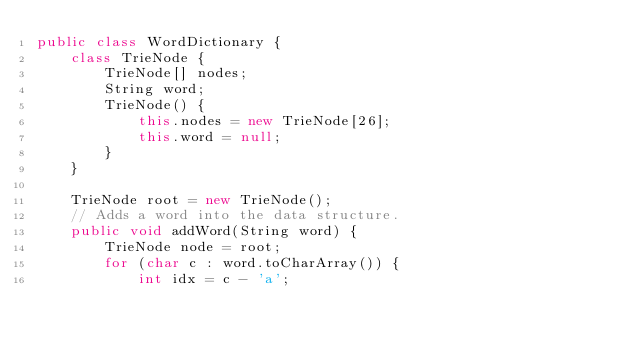<code> <loc_0><loc_0><loc_500><loc_500><_Java_>public class WordDictionary {
    class TrieNode {
        TrieNode[] nodes;
        String word;
        TrieNode() {
            this.nodes = new TrieNode[26];
            this.word = null;
        }
    }
    
    TrieNode root = new TrieNode();
    // Adds a word into the data structure.
    public void addWord(String word) {
        TrieNode node = root;
        for (char c : word.toCharArray()) {
            int idx = c - 'a';</code> 